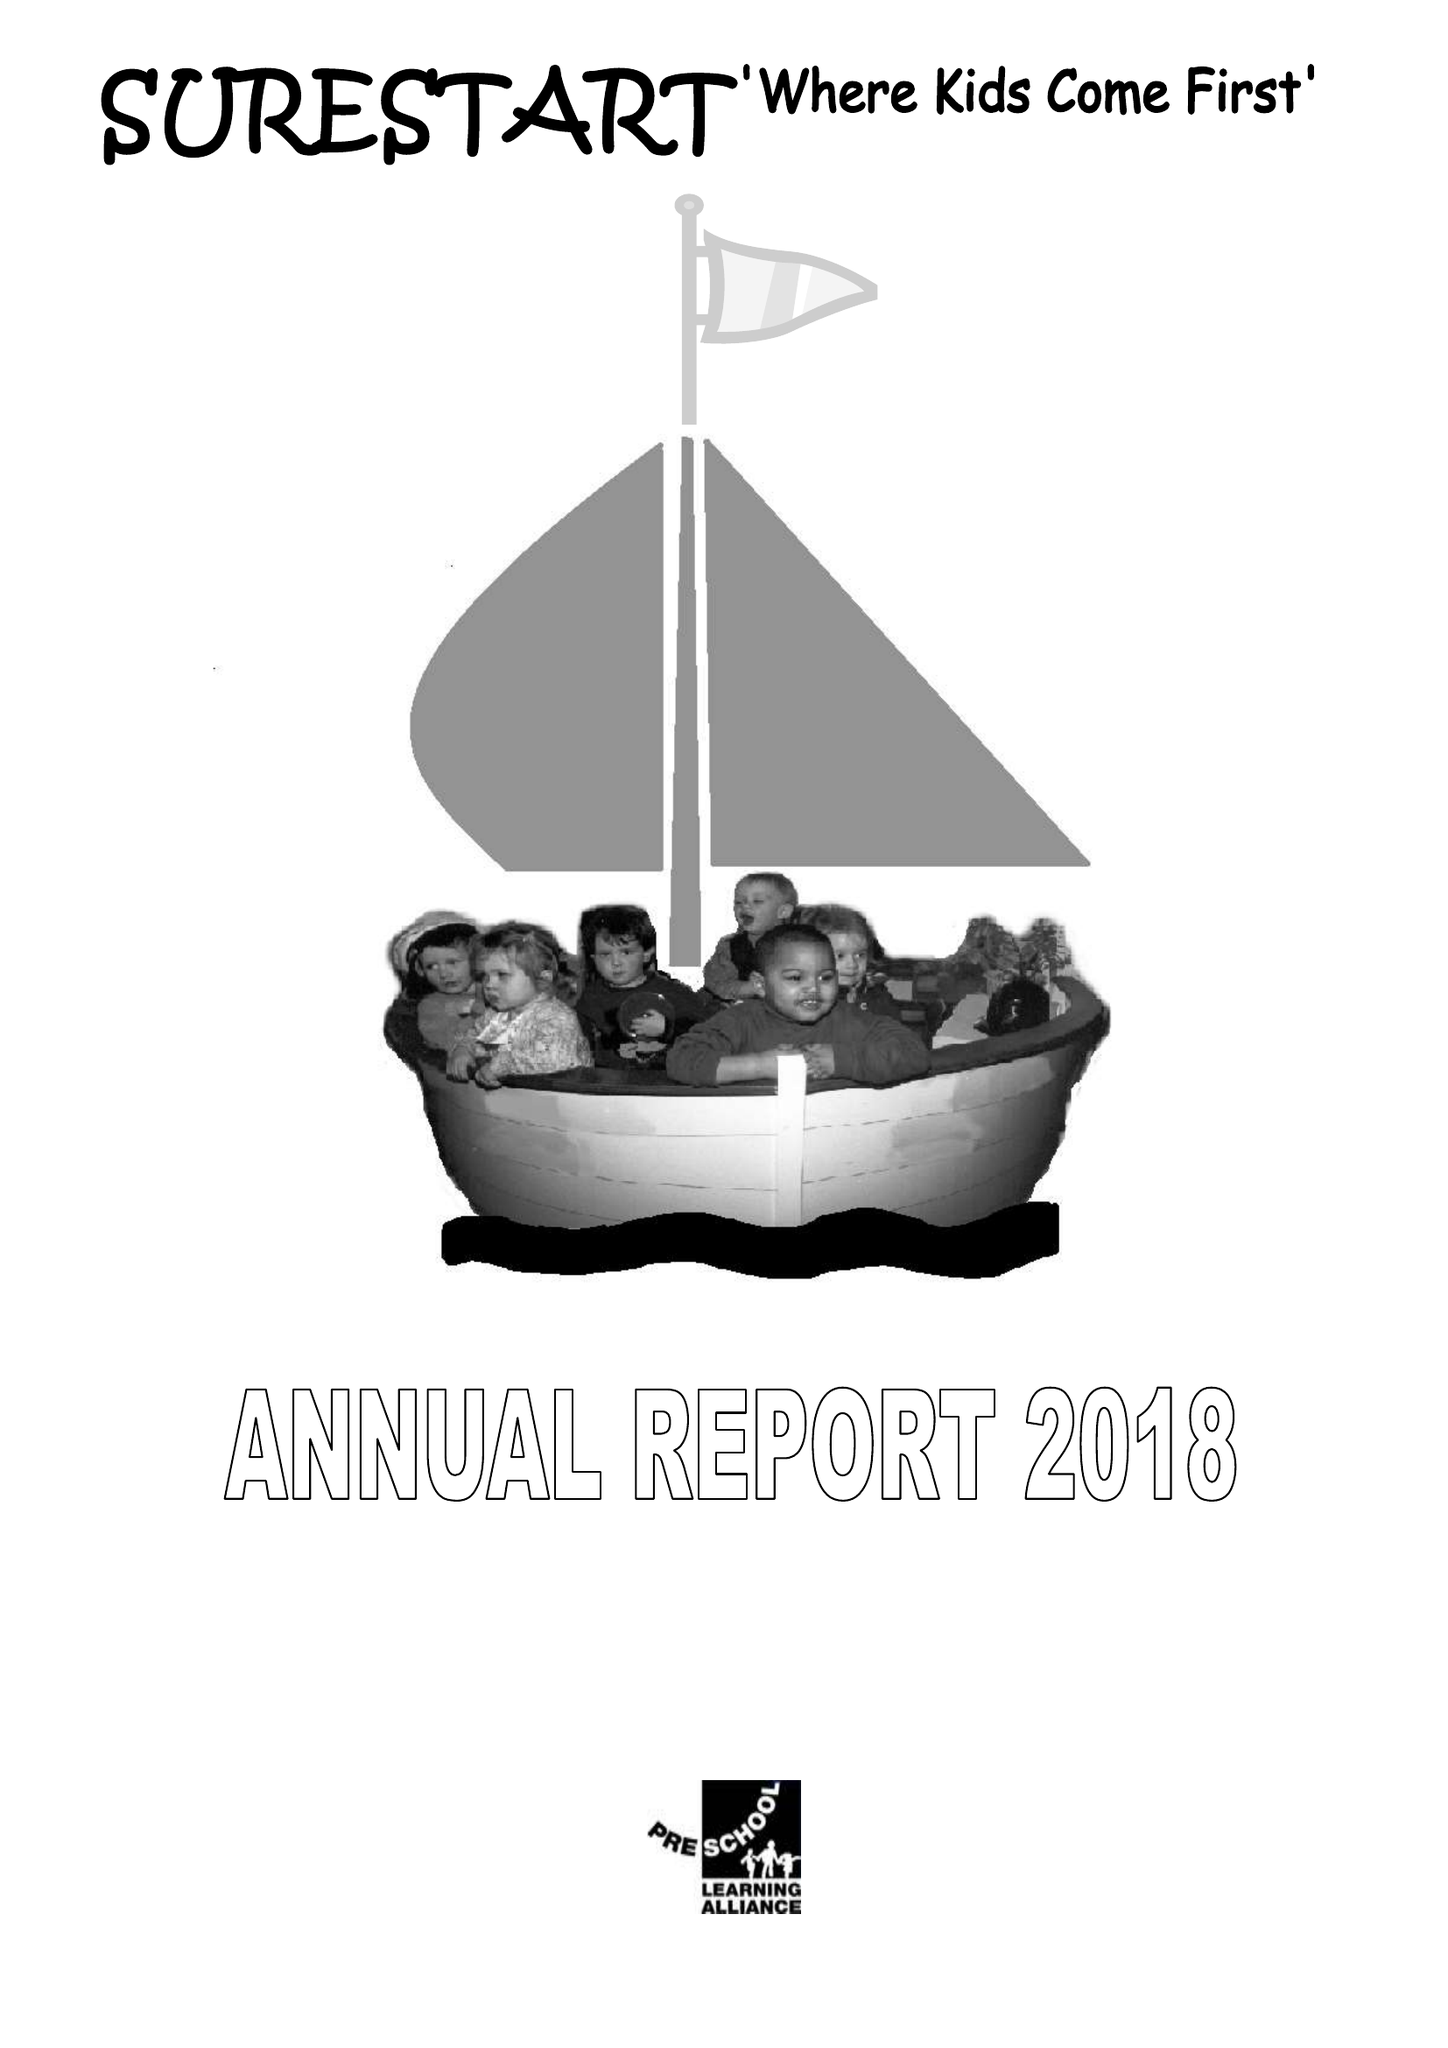What is the value for the report_date?
Answer the question using a single word or phrase. 2018-03-31 